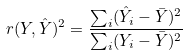<formula> <loc_0><loc_0><loc_500><loc_500>r ( Y , { \hat { Y } } ) ^ { 2 } = { \frac { \sum _ { i } ( { \hat { Y } } _ { i } - { \bar { Y } } ) ^ { 2 } } { \sum _ { i } ( Y _ { i } - { \bar { Y } } ) ^ { 2 } } }</formula> 